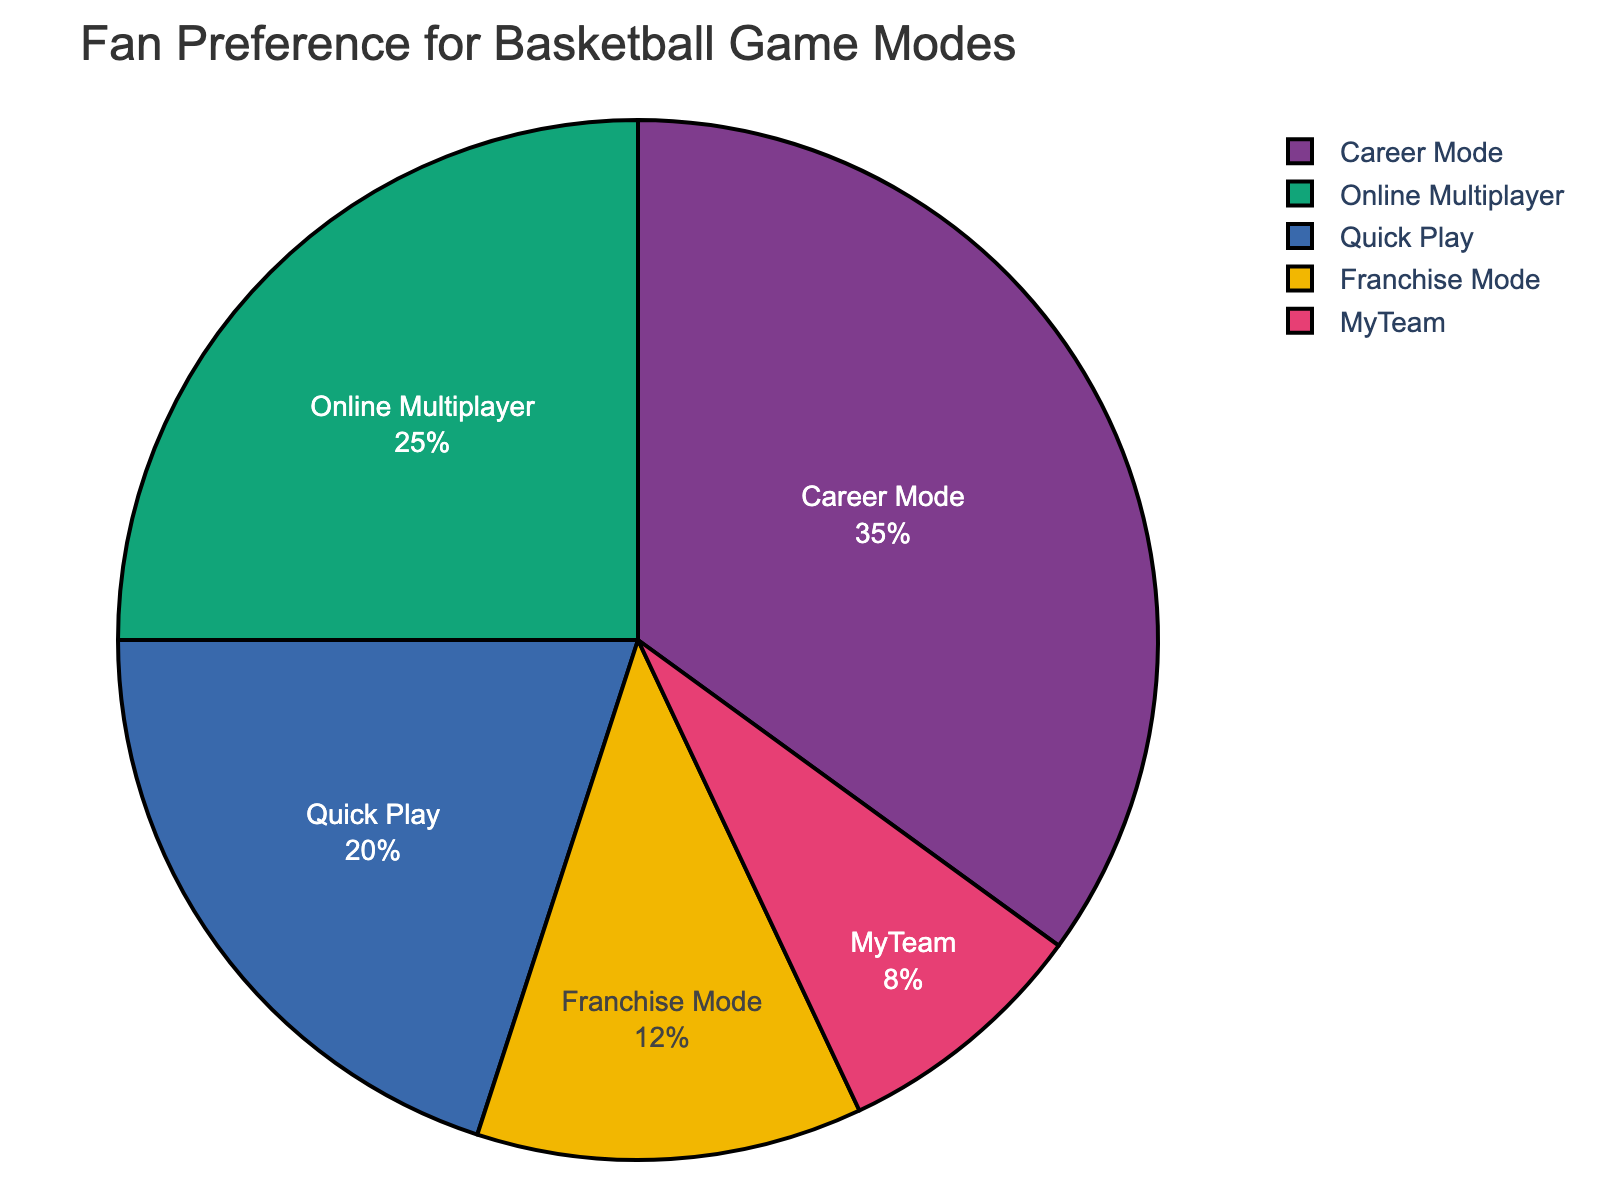Which game mode has the highest fan preference? The pie chart shows that Career Mode has the largest section, with 35% of the fan preferences.
Answer: Career Mode What is the combined percentage of fans preferring Franchise Mode and MyTeam? The percentages for Franchise Mode and MyTeam are 12% and 8% respectively. Adding them together results in 12% + 8% = 20%.
Answer: 20% Is Quick Play more popular than Online Multiplayer? Quick Play has a 20% preference, while Online Multiplayer has 25%. Since 20% is less than 25%, Quick Play is less popular than Online Multiplayer.
Answer: No How much less popular is MyTeam compared to Career Mode? Comparing the percentages, Career Mode has 35% and MyTeam has 8%. The difference is 35% - 8% = 27%.
Answer: 27% What is the least popular game mode? The pie chart shows MyTeam has the smallest section, indicating it is the least popular with 8%.
Answer: MyTeam If we combine Quick Play and Online Multiplayer, what fraction of the total fan preference do they hold together? Quick Play is 20% and Online Multiplayer is 25%. Combined, they sum to 45%. This fraction is 45/100 or simplified as 9/20.
Answer: 9/20 Which segment in the pie chart is the most visually distinct? The pie chart uses color to distinguish segments. Typically, the largest segment, Career Mode, at 35%, is also the most visually distinct due to its size and prominence.
Answer: Career Mode (visually largest segment) How much more popular is the Online Multiplayer mode compared to Franchise Mode? Online Multiplayer has 25% fan preference while Franchise Mode has 12%. The difference is 25% - 12% = 13%.
Answer: 13% What is the sum of the percentages of the game modes preferred by less than 30% of fans? The game modes preferred by less than 30% of fans are: Quick Play (20%), Online Multiplayer (25%), Franchise Mode (12%), and MyTeam (8%). Summing them gives 20% + 25% + 12% + 8% = 65%.
Answer: 65% 